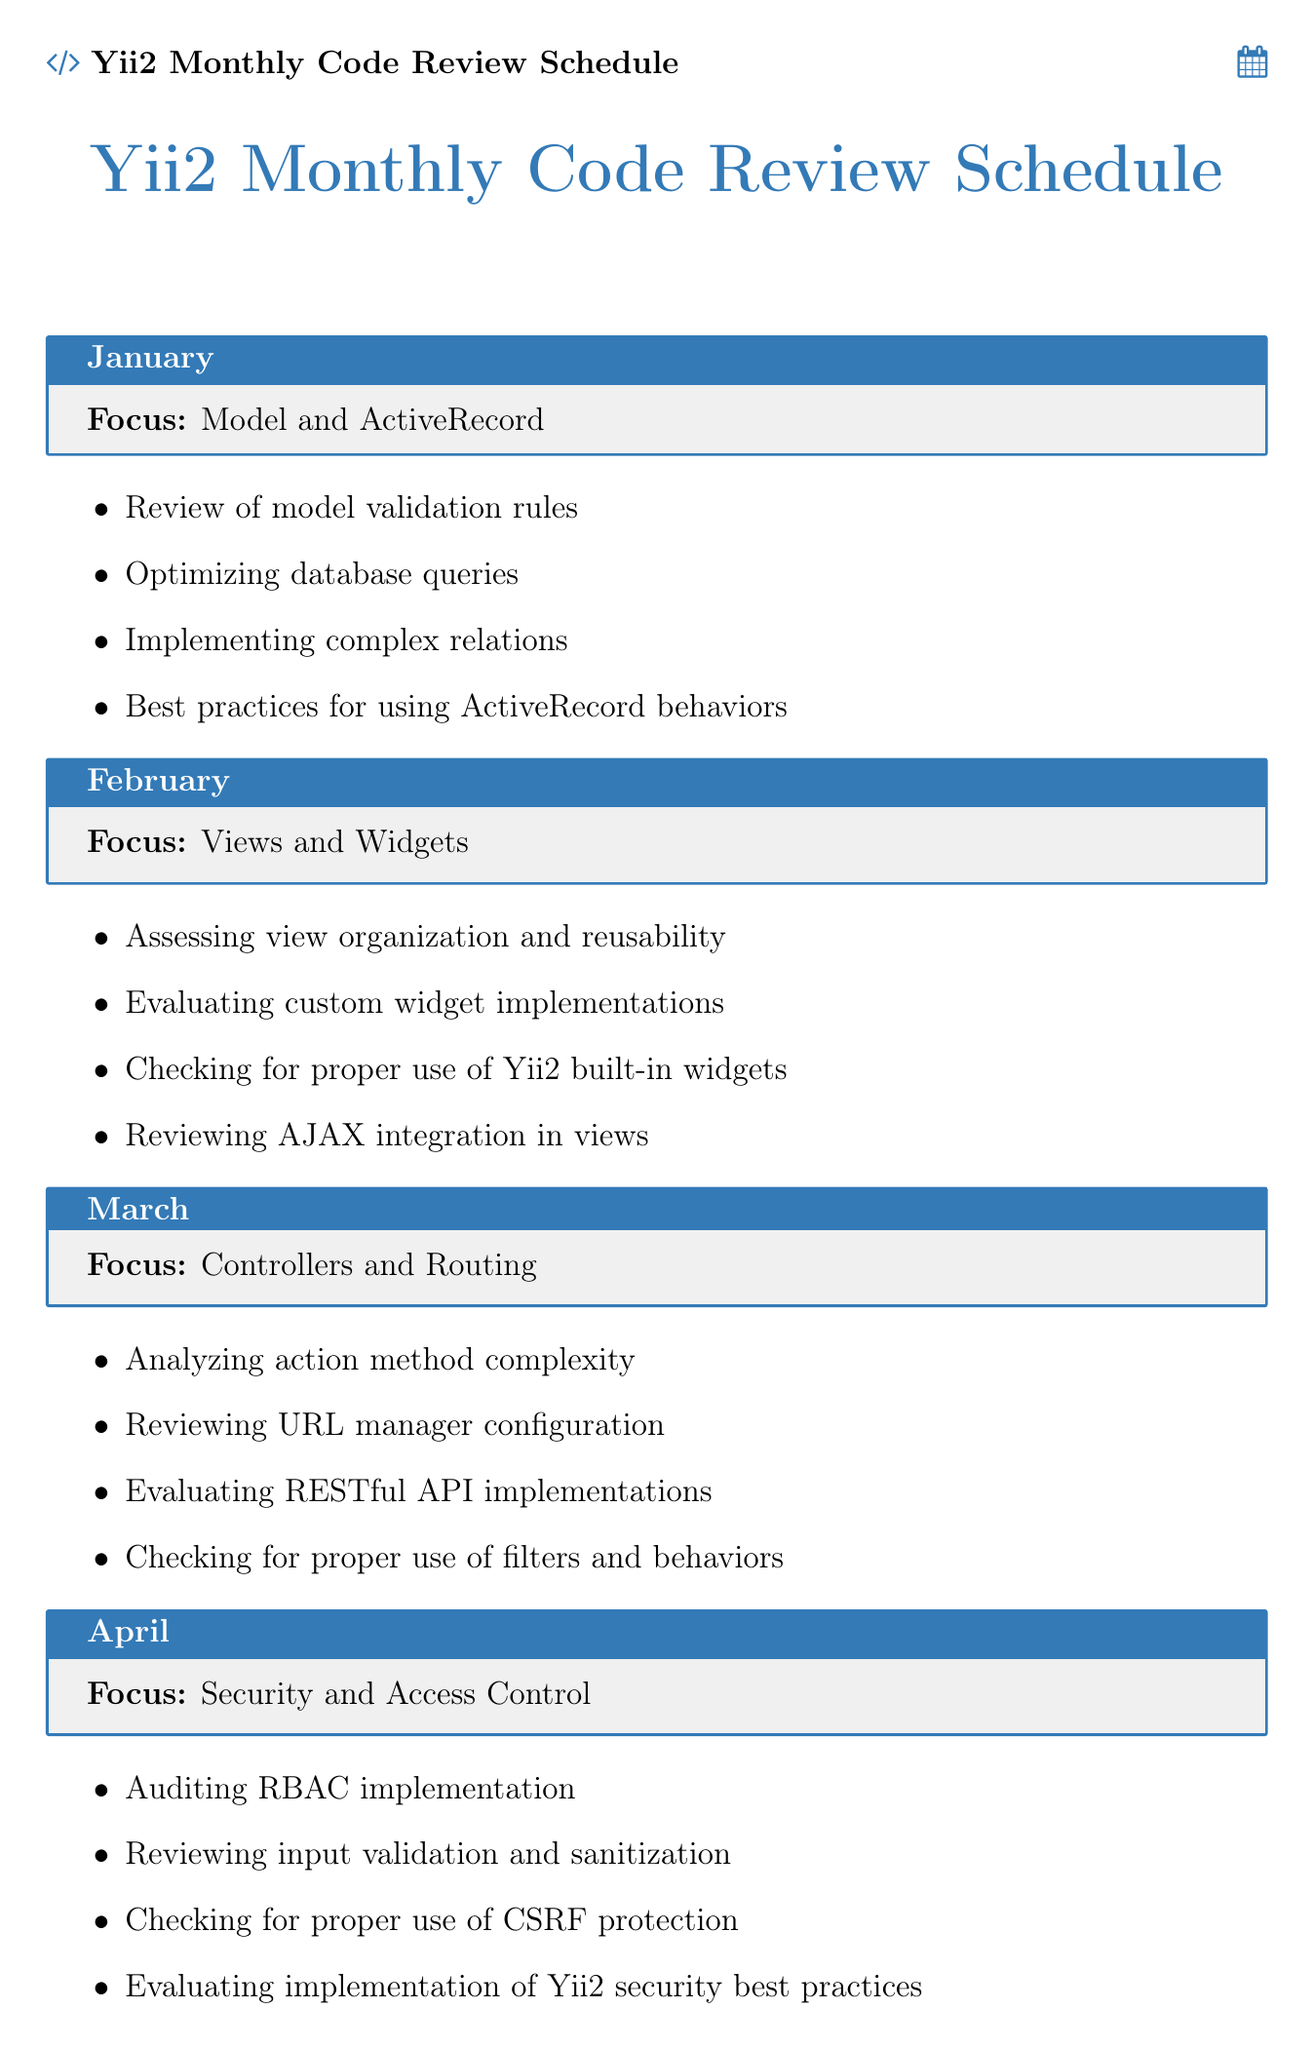What is the focus for January? The focus for January is found in the monthly schedule under the "focus" section for January.
Answer: Model and ActiveRecord How many topics are covered in the focus area of Security and Access Control? The number of topics can be counted from the specific month's topic list in the schedule.
Answer: Four Which month focuses on Performance Optimization? The specific month focusing on Performance Optimization can be identified directly from the schedule.
Answer: May What is the main topic of December? The main topic for December is listed in the schedule under the "focus" section for that month.
Answer: Code Architecture and Design Patterns How many focus areas are there in total? The total number of focus areas can be determined by counting the number of entries in the monthly schedule.
Answer: Twelve What is reviewed in August? The topics listed for August specify what is reviewed in that month from the schedule.
Answer: Error Handling and Logging When is the focus on Testing and Quality Assurance scheduled? The month associated with Testing and Quality Assurance can be found directly in the schedule.
Answer: September What is assessed in the month of July? The assessment topic for July can be found in the main focus description for that month.
Answer: Forms and Model Scenarios 